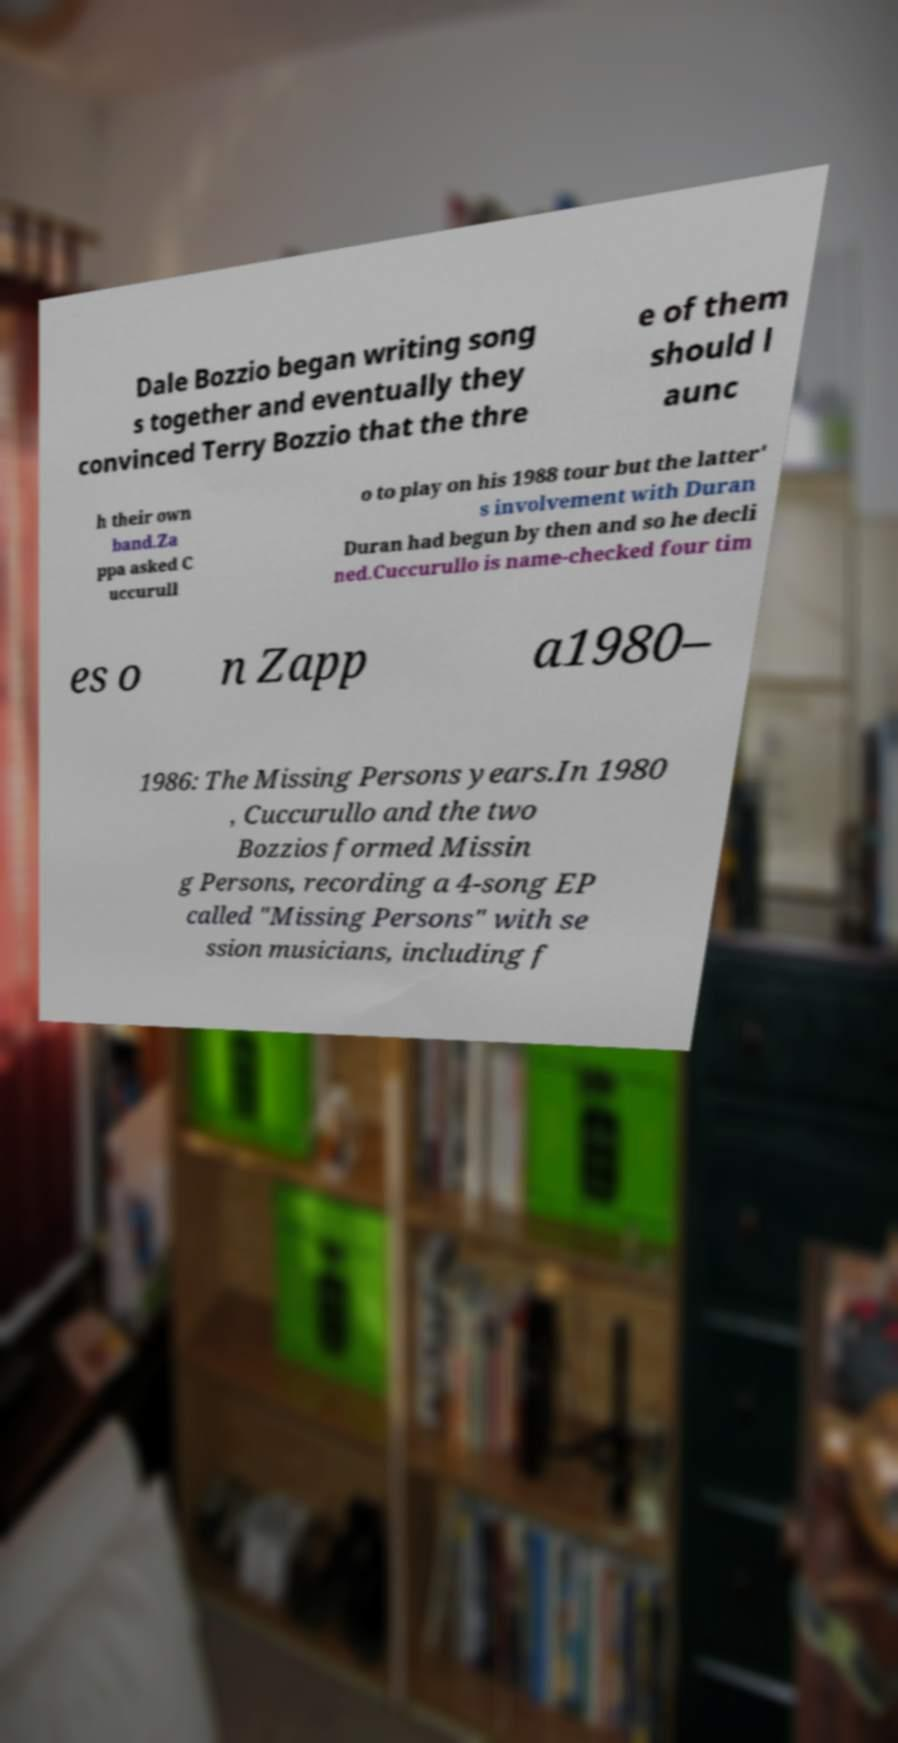Can you tell me more about the band 'Missing Persons' and its impact on the music scene? Missing Persons was a new wave band formed in the early 1980s by Dale and Terry Bozzio, and Warren Cuccurullo. Known for their unique sound and visual style, they produced hits like 'Words' and 'Walking in L.A.' They were instrumental in defining the New Wave genre, influencing various artists and music styles in the following decades. 